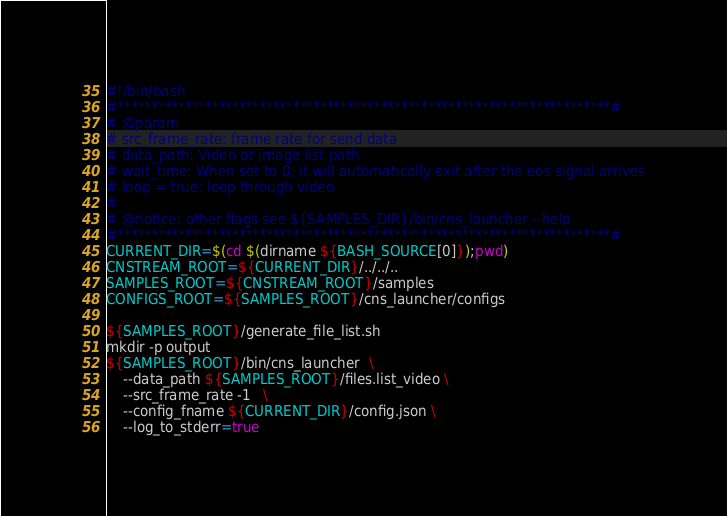Convert code to text. <code><loc_0><loc_0><loc_500><loc_500><_Bash_>#!/bin/bash
#*************************************************************************#
# @param
# src_frame_rate: frame rate for send data
# data_path: Video or image list path
# wait_time: When set to 0, it will automatically exit after the eos signal arrives
# loop = true: loop through video
#
# @notice: other flags see ${SAMPLES_DIR}/bin/cns_launcher --help
#*************************************************************************#
CURRENT_DIR=$(cd $(dirname ${BASH_SOURCE[0]});pwd)
CNSTREAM_ROOT=${CURRENT_DIR}/../../..
SAMPLES_ROOT=${CNSTREAM_ROOT}/samples
CONFIGS_ROOT=${SAMPLES_ROOT}/cns_launcher/configs

${SAMPLES_ROOT}/generate_file_list.sh
mkdir -p output
${SAMPLES_ROOT}/bin/cns_launcher  \
    --data_path ${SAMPLES_ROOT}/files.list_video \
    --src_frame_rate -1   \
    --config_fname ${CURRENT_DIR}/config.json \
    --log_to_stderr=true

</code> 